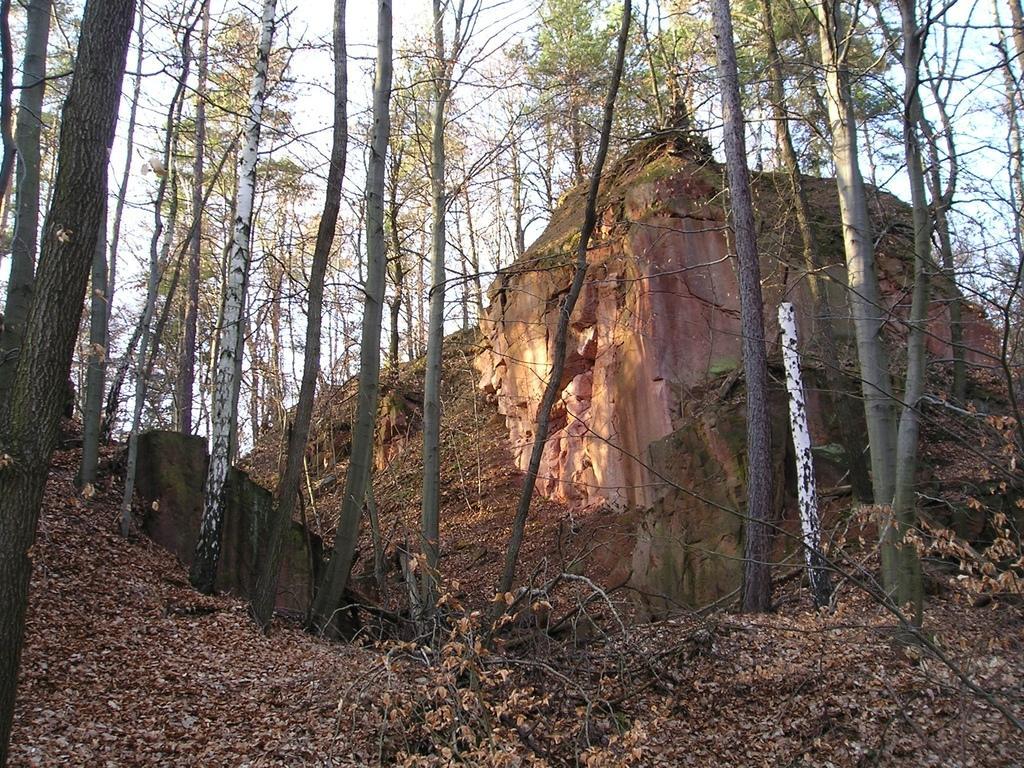How would you summarize this image in a sentence or two? Here in this picture we can see rock stones present on the ground over there and we can see trees present all over there and we can also see leaves present on the ground over there. 